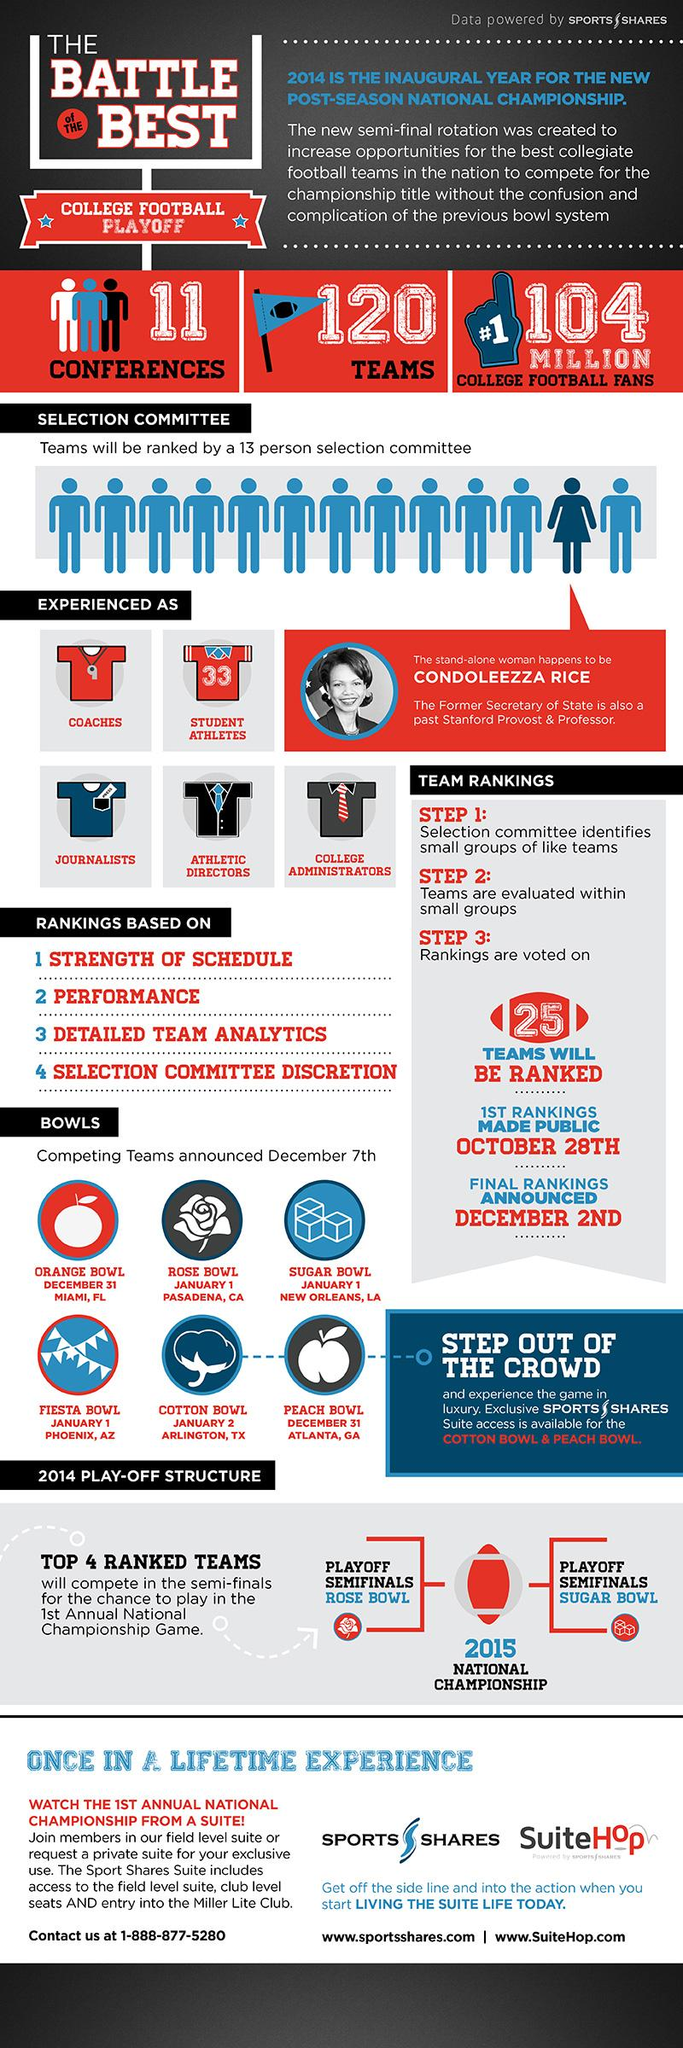Draw attention to some important aspects in this diagram. The Fiesta Bowl is scheduled to take place in Phoenix, Arizona. Six Bowl games are listed. The Rose Bowl event is scheduled to take place on January 1 in Pasadena, California. The Peach Bowl is scheduled to be held at Atlanta, Georgia on December 31. The Orange Bowl match is scheduled to be held on December 31. 